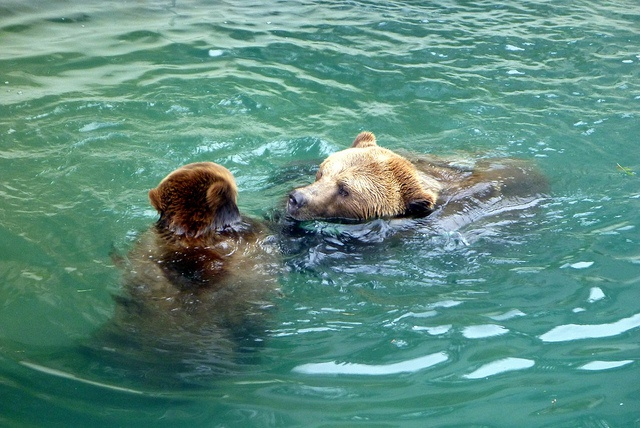Describe the objects in this image and their specific colors. I can see bear in darkgray, black, gray, teal, and darkgreen tones and bear in darkgray, beige, tan, gray, and black tones in this image. 